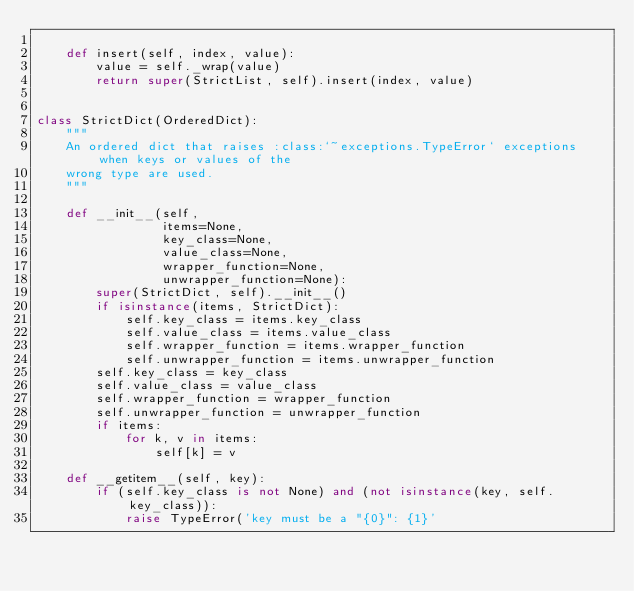Convert code to text. <code><loc_0><loc_0><loc_500><loc_500><_Python_>
    def insert(self, index, value):
        value = self._wrap(value)
        return super(StrictList, self).insert(index, value)


class StrictDict(OrderedDict):
    """
    An ordered dict that raises :class:`~exceptions.TypeError` exceptions when keys or values of the
    wrong type are used.
    """

    def __init__(self,
                 items=None,
                 key_class=None,
                 value_class=None,
                 wrapper_function=None,
                 unwrapper_function=None):
        super(StrictDict, self).__init__()
        if isinstance(items, StrictDict):
            self.key_class = items.key_class
            self.value_class = items.value_class
            self.wrapper_function = items.wrapper_function
            self.unwrapper_function = items.unwrapper_function
        self.key_class = key_class
        self.value_class = value_class
        self.wrapper_function = wrapper_function
        self.unwrapper_function = unwrapper_function
        if items:
            for k, v in items:
                self[k] = v

    def __getitem__(self, key):
        if (self.key_class is not None) and (not isinstance(key, self.key_class)):
            raise TypeError('key must be a "{0}": {1}'</code> 